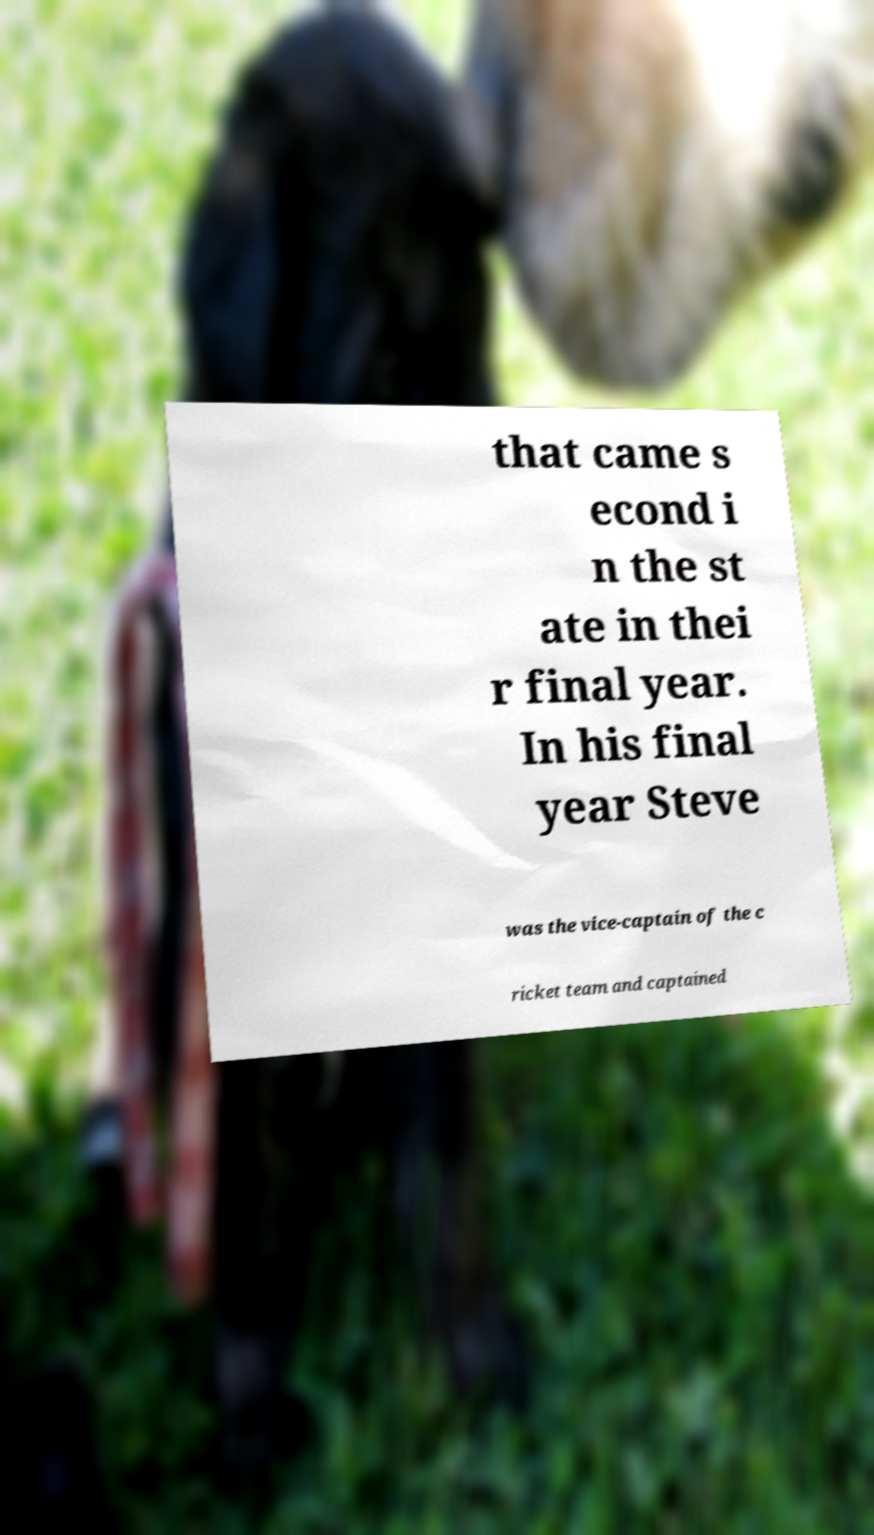There's text embedded in this image that I need extracted. Can you transcribe it verbatim? that came s econd i n the st ate in thei r final year. In his final year Steve was the vice-captain of the c ricket team and captained 